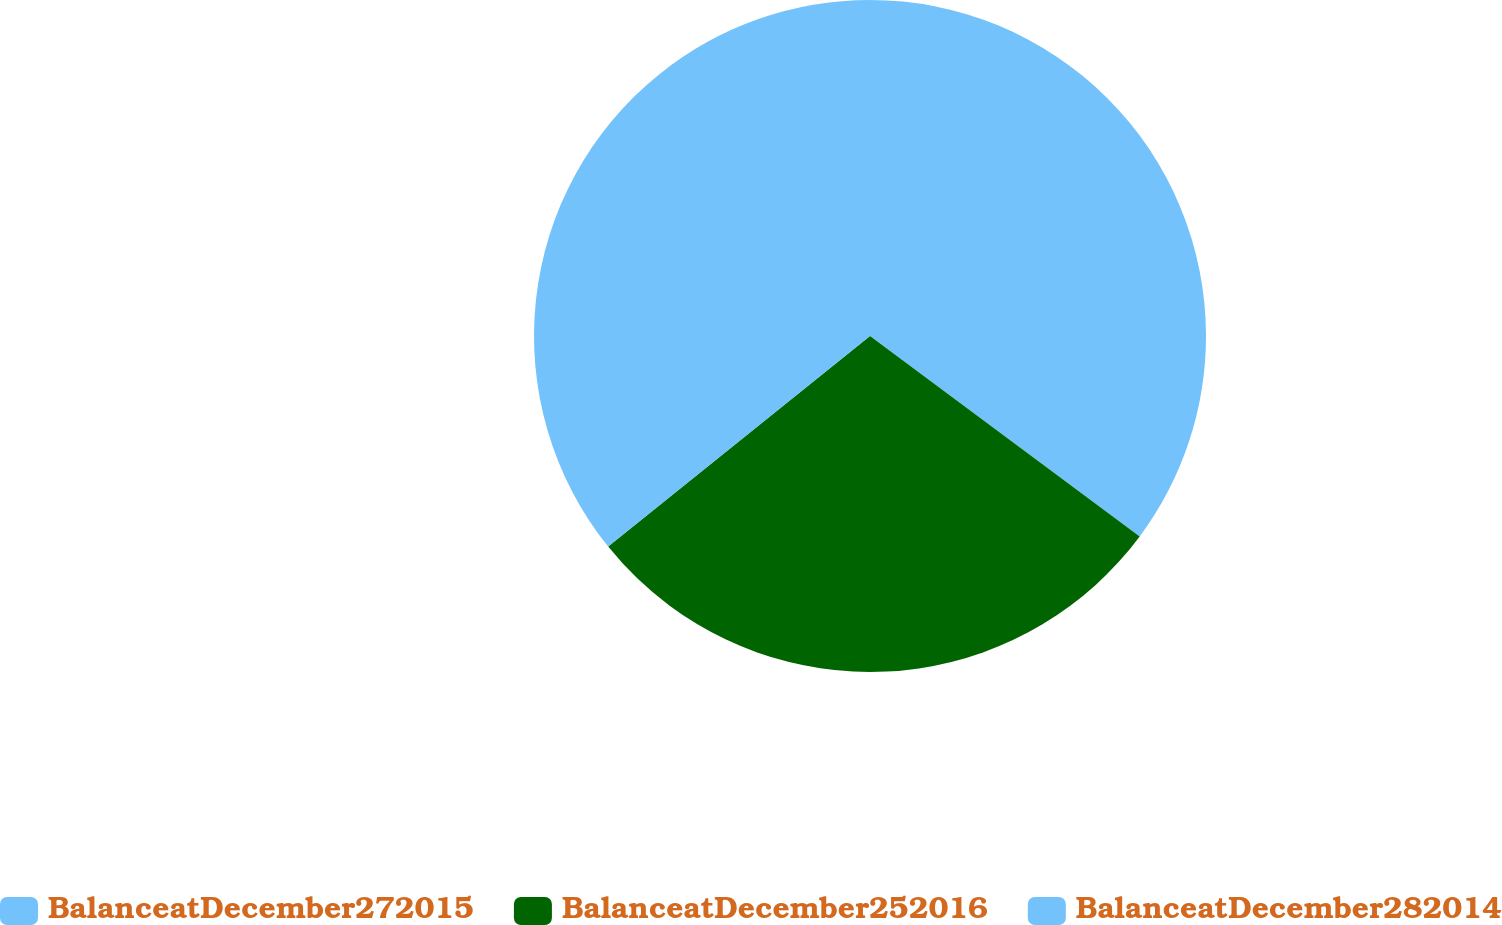Convert chart to OTSL. <chart><loc_0><loc_0><loc_500><loc_500><pie_chart><fcel>BalanceatDecember272015<fcel>BalanceatDecember252016<fcel>BalanceatDecember282014<nl><fcel>35.17%<fcel>29.05%<fcel>35.78%<nl></chart> 